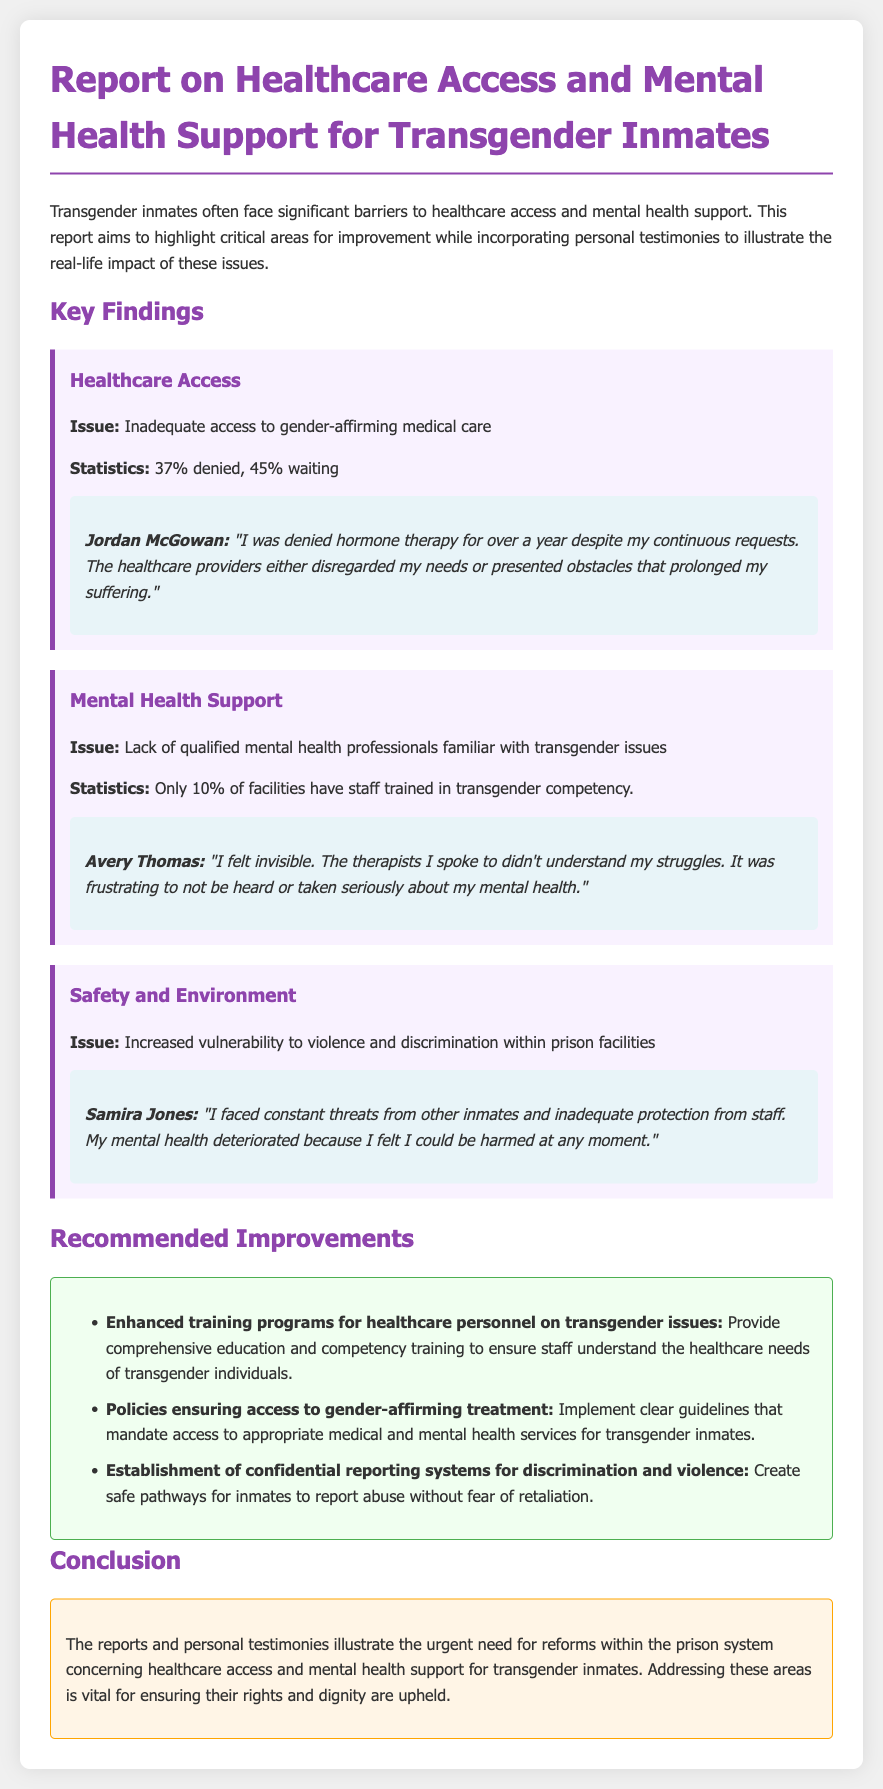What percentage of transgender inmates were denied hormone therapy? The document states that 37% of transgender inmates were denied hormone therapy.
Answer: 37% What percentage of facilities have staff trained in transgender competency? According to the report, only 10% of facilities have staff trained in transgender competency.
Answer: 10% Who provided a testimony about being denied hormone therapy? The testimony about being denied hormone therapy was provided by Jordan McGowan.
Answer: Jordan McGowan What is one recommended improvement for healthcare personnel? One recommended improvement is "Enhanced training programs for healthcare personnel on transgender issues."
Answer: Enhanced training programs What issue did Samira Jones highlight in her testimony? Samira Jones highlighted the issue of increased vulnerability to violence and discrimination within prison facilities.
Answer: Increased vulnerability to violence What is one of the statistics mentioned regarding transgender inmates waiting for medical care? The document states that 45% of transgender inmates are waiting for medical care.
Answer: 45% What is the main focus of the report? The focus of the report is on healthcare access and mental health support for transgender inmates.
Answer: Healthcare access and mental health support What is a key issue identified concerning mental health support? A key issue identified is the lack of qualified mental health professionals familiar with transgender issues.
Answer: Lack of qualified professionals What does the report suggest for reporting discrimination and violence? The report suggests the establishment of confidential reporting systems for discrimination and violence.
Answer: Confidential reporting systems 